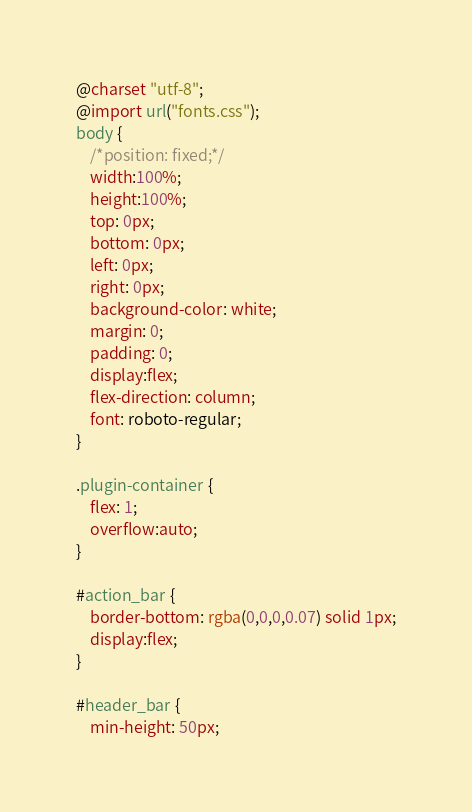Convert code to text. <code><loc_0><loc_0><loc_500><loc_500><_CSS_>@charset "utf-8";
@import url("fonts.css");
body {
	/*position: fixed;*/
	width:100%;
	height:100%;
	top: 0px;
	bottom: 0px;
	left: 0px;
	right: 0px;
	background-color: white;
	margin: 0;
	padding: 0;
	display:flex;
	flex-direction: column;
	font: roboto-regular;
}

.plugin-container {
	flex: 1;
	overflow:auto;
}

#action_bar {
	border-bottom: rgba(0,0,0,0.07) solid 1px;
	display:flex;
}

#header_bar {
	min-height: 50px;</code> 